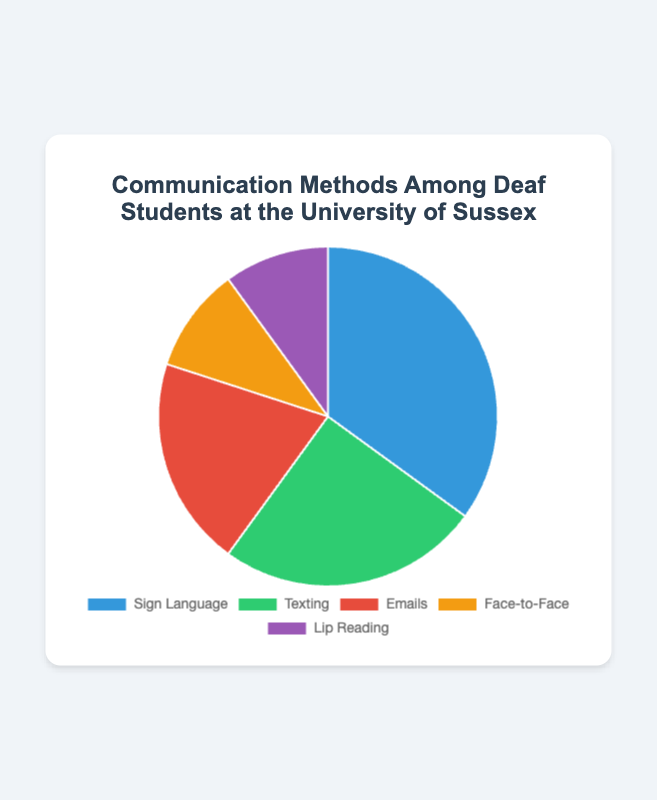What communication method is used the most among deaf students at the University of Sussex? The largest segment on the pie chart indicates the most used communication method. This part is colored in blue and labeled as "Sign Language," representing 35% of the distribution.
Answer: Sign Language What is the combined percentage of students using either texting or emails? To find the combined percentage, add the percentages for texting and emails: 25% (texting) + 20% (emails).
Answer: 45% By how much does the percentage of students who use sign language exceed the percentage of students who use face-to-face communication? The percentage for sign language is 35% and for face-to-face is 10%. To find the difference, subtract 10% from 35%.
Answer: 25% Which communication methods have the same percentage of use among deaf students? The pie chart shows two segments of equal size, labeled "Face-to-Face" and "Lip Reading," both representing 10%.
Answer: Face-to-Face and Lip Reading What is the difference between the most and the least commonly used communication methods? The most commonly used method is Sign Language at 35%, and the least commonly used methods are Face-to-Face and Lip Reading, each at 10%. The difference is 35% - 10%.
Answer: 25% What percentage of students prefer communication methods other than sign language? Subtract the percentage of sign language use (35%) from the total (100%) to find the percentage of students using other methods.
Answer: 65% Which communication method is the second most commonly used among deaf students? The second largest segment on the pie chart is labeled "Texting," representing 25%.
Answer: Texting What is the average percentage of students using face-to-face and lip reading methods? To find the average, add the percentages for face-to-face (10%) and lip reading (10%), then divide by 2. (10% + 10%) / 2
Answer: 10% If you combine the percentages of the three least used communication methods, what is the total percentage? Add the percentages for emails (20%), face-to-face (10%), and lip reading (10%): 20% + 10% + 10%.
Answer: 40% What is the ratio of students using sign language to those using texting? The percentage for sign language is 35% and for texting is 25%. The ratio of sign language to texting is 35:25, which simplifies to 7:5.
Answer: 7:5 